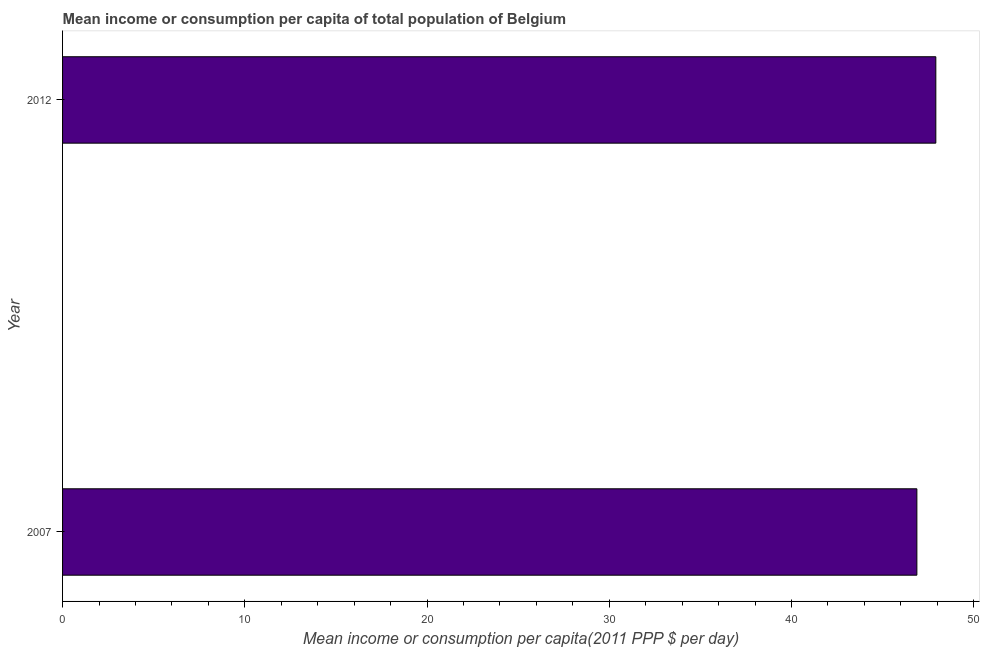Does the graph contain any zero values?
Keep it short and to the point. No. Does the graph contain grids?
Offer a very short reply. No. What is the title of the graph?
Provide a succinct answer. Mean income or consumption per capita of total population of Belgium. What is the label or title of the X-axis?
Your answer should be compact. Mean income or consumption per capita(2011 PPP $ per day). What is the mean income or consumption in 2012?
Your answer should be very brief. 47.92. Across all years, what is the maximum mean income or consumption?
Make the answer very short. 47.92. Across all years, what is the minimum mean income or consumption?
Give a very brief answer. 46.88. In which year was the mean income or consumption maximum?
Make the answer very short. 2012. What is the sum of the mean income or consumption?
Offer a terse response. 94.8. What is the difference between the mean income or consumption in 2007 and 2012?
Give a very brief answer. -1.04. What is the average mean income or consumption per year?
Keep it short and to the point. 47.4. What is the median mean income or consumption?
Your answer should be compact. 47.4. In how many years, is the mean income or consumption greater than the average mean income or consumption taken over all years?
Your response must be concise. 1. How many bars are there?
Ensure brevity in your answer.  2. What is the difference between two consecutive major ticks on the X-axis?
Offer a very short reply. 10. What is the Mean income or consumption per capita(2011 PPP $ per day) in 2007?
Provide a succinct answer. 46.88. What is the Mean income or consumption per capita(2011 PPP $ per day) of 2012?
Your answer should be very brief. 47.92. What is the difference between the Mean income or consumption per capita(2011 PPP $ per day) in 2007 and 2012?
Your answer should be very brief. -1.04. 